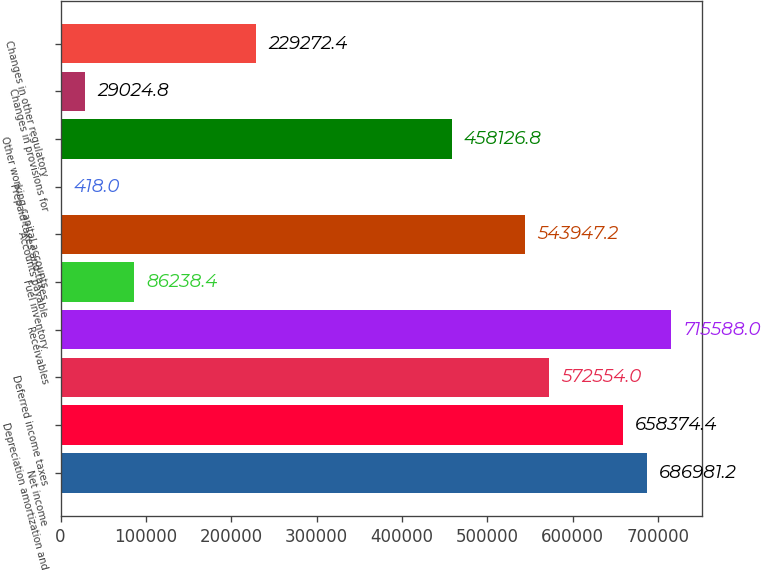Convert chart. <chart><loc_0><loc_0><loc_500><loc_500><bar_chart><fcel>Net income<fcel>Depreciation amortization and<fcel>Deferred income taxes<fcel>Receivables<fcel>Fuel inventory<fcel>Accounts payable<fcel>Prepaid taxes and taxes<fcel>Other working capital accounts<fcel>Changes in provisions for<fcel>Changes in other regulatory<nl><fcel>686981<fcel>658374<fcel>572554<fcel>715588<fcel>86238.4<fcel>543947<fcel>418<fcel>458127<fcel>29024.8<fcel>229272<nl></chart> 